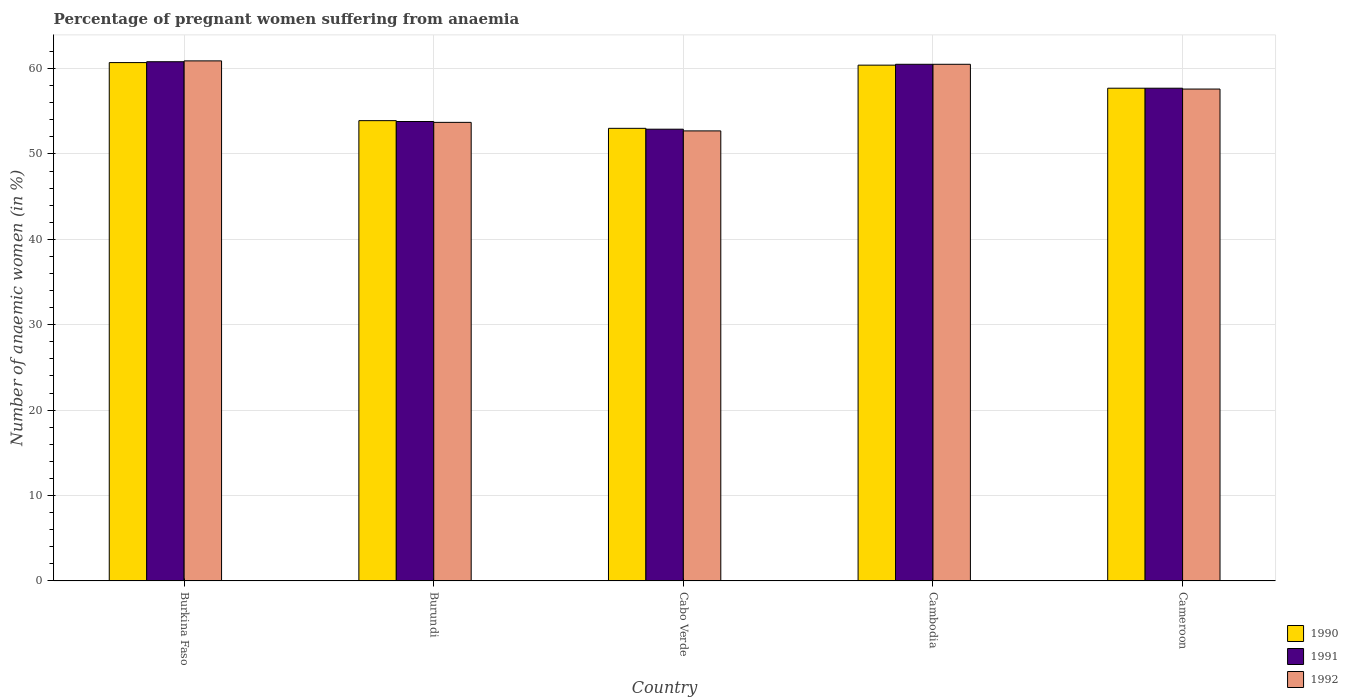How many different coloured bars are there?
Provide a succinct answer. 3. How many groups of bars are there?
Keep it short and to the point. 5. Are the number of bars on each tick of the X-axis equal?
Make the answer very short. Yes. How many bars are there on the 1st tick from the right?
Offer a very short reply. 3. What is the label of the 5th group of bars from the left?
Provide a succinct answer. Cameroon. What is the number of anaemic women in 1991 in Burundi?
Ensure brevity in your answer.  53.8. Across all countries, what is the maximum number of anaemic women in 1992?
Your answer should be very brief. 60.9. Across all countries, what is the minimum number of anaemic women in 1991?
Keep it short and to the point. 52.9. In which country was the number of anaemic women in 1991 maximum?
Ensure brevity in your answer.  Burkina Faso. In which country was the number of anaemic women in 1991 minimum?
Give a very brief answer. Cabo Verde. What is the total number of anaemic women in 1990 in the graph?
Give a very brief answer. 285.7. What is the difference between the number of anaemic women in 1992 in Burundi and that in Cambodia?
Offer a terse response. -6.8. What is the difference between the number of anaemic women in 1990 in Cabo Verde and the number of anaemic women in 1991 in Burkina Faso?
Make the answer very short. -7.8. What is the average number of anaemic women in 1992 per country?
Make the answer very short. 57.08. What is the difference between the number of anaemic women of/in 1990 and number of anaemic women of/in 1992 in Cabo Verde?
Make the answer very short. 0.3. In how many countries, is the number of anaemic women in 1991 greater than 26 %?
Your response must be concise. 5. What is the ratio of the number of anaemic women in 1990 in Burundi to that in Cambodia?
Your answer should be very brief. 0.89. What is the difference between the highest and the lowest number of anaemic women in 1990?
Ensure brevity in your answer.  7.7. In how many countries, is the number of anaemic women in 1990 greater than the average number of anaemic women in 1990 taken over all countries?
Your response must be concise. 3. How many countries are there in the graph?
Your answer should be very brief. 5. Are the values on the major ticks of Y-axis written in scientific E-notation?
Your answer should be compact. No. Does the graph contain grids?
Give a very brief answer. Yes. Where does the legend appear in the graph?
Offer a very short reply. Bottom right. How many legend labels are there?
Your response must be concise. 3. What is the title of the graph?
Provide a short and direct response. Percentage of pregnant women suffering from anaemia. Does "2001" appear as one of the legend labels in the graph?
Ensure brevity in your answer.  No. What is the label or title of the Y-axis?
Offer a terse response. Number of anaemic women (in %). What is the Number of anaemic women (in %) of 1990 in Burkina Faso?
Ensure brevity in your answer.  60.7. What is the Number of anaemic women (in %) in 1991 in Burkina Faso?
Provide a succinct answer. 60.8. What is the Number of anaemic women (in %) in 1992 in Burkina Faso?
Keep it short and to the point. 60.9. What is the Number of anaemic women (in %) in 1990 in Burundi?
Keep it short and to the point. 53.9. What is the Number of anaemic women (in %) of 1991 in Burundi?
Offer a very short reply. 53.8. What is the Number of anaemic women (in %) in 1992 in Burundi?
Provide a succinct answer. 53.7. What is the Number of anaemic women (in %) of 1990 in Cabo Verde?
Offer a very short reply. 53. What is the Number of anaemic women (in %) in 1991 in Cabo Verde?
Your answer should be very brief. 52.9. What is the Number of anaemic women (in %) in 1992 in Cabo Verde?
Provide a succinct answer. 52.7. What is the Number of anaemic women (in %) of 1990 in Cambodia?
Give a very brief answer. 60.4. What is the Number of anaemic women (in %) in 1991 in Cambodia?
Provide a short and direct response. 60.5. What is the Number of anaemic women (in %) of 1992 in Cambodia?
Keep it short and to the point. 60.5. What is the Number of anaemic women (in %) of 1990 in Cameroon?
Make the answer very short. 57.7. What is the Number of anaemic women (in %) of 1991 in Cameroon?
Provide a short and direct response. 57.7. What is the Number of anaemic women (in %) in 1992 in Cameroon?
Make the answer very short. 57.6. Across all countries, what is the maximum Number of anaemic women (in %) of 1990?
Give a very brief answer. 60.7. Across all countries, what is the maximum Number of anaemic women (in %) in 1991?
Make the answer very short. 60.8. Across all countries, what is the maximum Number of anaemic women (in %) of 1992?
Offer a very short reply. 60.9. Across all countries, what is the minimum Number of anaemic women (in %) in 1990?
Give a very brief answer. 53. Across all countries, what is the minimum Number of anaemic women (in %) of 1991?
Provide a succinct answer. 52.9. Across all countries, what is the minimum Number of anaemic women (in %) in 1992?
Keep it short and to the point. 52.7. What is the total Number of anaemic women (in %) of 1990 in the graph?
Offer a terse response. 285.7. What is the total Number of anaemic women (in %) of 1991 in the graph?
Your answer should be compact. 285.7. What is the total Number of anaemic women (in %) in 1992 in the graph?
Give a very brief answer. 285.4. What is the difference between the Number of anaemic women (in %) in 1990 in Burkina Faso and that in Burundi?
Keep it short and to the point. 6.8. What is the difference between the Number of anaemic women (in %) in 1990 in Burkina Faso and that in Cabo Verde?
Give a very brief answer. 7.7. What is the difference between the Number of anaemic women (in %) of 1991 in Burkina Faso and that in Cabo Verde?
Provide a short and direct response. 7.9. What is the difference between the Number of anaemic women (in %) of 1990 in Burkina Faso and that in Cameroon?
Offer a terse response. 3. What is the difference between the Number of anaemic women (in %) of 1991 in Burkina Faso and that in Cameroon?
Give a very brief answer. 3.1. What is the difference between the Number of anaemic women (in %) of 1990 in Burundi and that in Cabo Verde?
Provide a short and direct response. 0.9. What is the difference between the Number of anaemic women (in %) of 1992 in Burundi and that in Cabo Verde?
Offer a very short reply. 1. What is the difference between the Number of anaemic women (in %) in 1990 in Burundi and that in Cambodia?
Keep it short and to the point. -6.5. What is the difference between the Number of anaemic women (in %) in 1992 in Burundi and that in Cameroon?
Provide a succinct answer. -3.9. What is the difference between the Number of anaemic women (in %) of 1990 in Cabo Verde and that in Cambodia?
Your response must be concise. -7.4. What is the difference between the Number of anaemic women (in %) in 1991 in Cabo Verde and that in Cambodia?
Keep it short and to the point. -7.6. What is the difference between the Number of anaemic women (in %) in 1990 in Cabo Verde and that in Cameroon?
Offer a very short reply. -4.7. What is the difference between the Number of anaemic women (in %) in 1991 in Cabo Verde and that in Cameroon?
Offer a terse response. -4.8. What is the difference between the Number of anaemic women (in %) in 1990 in Cambodia and that in Cameroon?
Provide a short and direct response. 2.7. What is the difference between the Number of anaemic women (in %) of 1991 in Cambodia and that in Cameroon?
Make the answer very short. 2.8. What is the difference between the Number of anaemic women (in %) of 1990 in Burkina Faso and the Number of anaemic women (in %) of 1991 in Burundi?
Your answer should be compact. 6.9. What is the difference between the Number of anaemic women (in %) of 1990 in Burkina Faso and the Number of anaemic women (in %) of 1992 in Burundi?
Your response must be concise. 7. What is the difference between the Number of anaemic women (in %) of 1990 in Burkina Faso and the Number of anaemic women (in %) of 1992 in Cabo Verde?
Your answer should be compact. 8. What is the difference between the Number of anaemic women (in %) in 1990 in Burkina Faso and the Number of anaemic women (in %) in 1992 in Cambodia?
Your answer should be very brief. 0.2. What is the difference between the Number of anaemic women (in %) in 1991 in Burkina Faso and the Number of anaemic women (in %) in 1992 in Cambodia?
Ensure brevity in your answer.  0.3. What is the difference between the Number of anaemic women (in %) of 1990 in Burkina Faso and the Number of anaemic women (in %) of 1992 in Cameroon?
Provide a succinct answer. 3.1. What is the difference between the Number of anaemic women (in %) in 1990 in Burundi and the Number of anaemic women (in %) in 1992 in Cabo Verde?
Offer a terse response. 1.2. What is the difference between the Number of anaemic women (in %) in 1991 in Burundi and the Number of anaemic women (in %) in 1992 in Cabo Verde?
Ensure brevity in your answer.  1.1. What is the difference between the Number of anaemic women (in %) in 1990 in Burundi and the Number of anaemic women (in %) in 1991 in Cambodia?
Make the answer very short. -6.6. What is the difference between the Number of anaemic women (in %) of 1990 in Burundi and the Number of anaemic women (in %) of 1992 in Cambodia?
Keep it short and to the point. -6.6. What is the difference between the Number of anaemic women (in %) of 1990 in Burundi and the Number of anaemic women (in %) of 1992 in Cameroon?
Provide a succinct answer. -3.7. What is the difference between the Number of anaemic women (in %) of 1990 in Cabo Verde and the Number of anaemic women (in %) of 1991 in Cambodia?
Offer a terse response. -7.5. What is the difference between the Number of anaemic women (in %) of 1991 in Cabo Verde and the Number of anaemic women (in %) of 1992 in Cambodia?
Provide a succinct answer. -7.6. What is the difference between the Number of anaemic women (in %) of 1990 in Cabo Verde and the Number of anaemic women (in %) of 1992 in Cameroon?
Offer a terse response. -4.6. What is the difference between the Number of anaemic women (in %) in 1991 in Cabo Verde and the Number of anaemic women (in %) in 1992 in Cameroon?
Give a very brief answer. -4.7. What is the average Number of anaemic women (in %) in 1990 per country?
Ensure brevity in your answer.  57.14. What is the average Number of anaemic women (in %) in 1991 per country?
Keep it short and to the point. 57.14. What is the average Number of anaemic women (in %) in 1992 per country?
Offer a terse response. 57.08. What is the difference between the Number of anaemic women (in %) of 1990 and Number of anaemic women (in %) of 1991 in Burkina Faso?
Provide a short and direct response. -0.1. What is the difference between the Number of anaemic women (in %) of 1991 and Number of anaemic women (in %) of 1992 in Burkina Faso?
Make the answer very short. -0.1. What is the difference between the Number of anaemic women (in %) in 1990 and Number of anaemic women (in %) in 1991 in Burundi?
Provide a succinct answer. 0.1. What is the difference between the Number of anaemic women (in %) in 1990 and Number of anaemic women (in %) in 1992 in Burundi?
Provide a short and direct response. 0.2. What is the difference between the Number of anaemic women (in %) in 1990 and Number of anaemic women (in %) in 1992 in Cabo Verde?
Make the answer very short. 0.3. What is the difference between the Number of anaemic women (in %) in 1990 and Number of anaemic women (in %) in 1992 in Cambodia?
Keep it short and to the point. -0.1. What is the ratio of the Number of anaemic women (in %) in 1990 in Burkina Faso to that in Burundi?
Give a very brief answer. 1.13. What is the ratio of the Number of anaemic women (in %) of 1991 in Burkina Faso to that in Burundi?
Your response must be concise. 1.13. What is the ratio of the Number of anaemic women (in %) of 1992 in Burkina Faso to that in Burundi?
Keep it short and to the point. 1.13. What is the ratio of the Number of anaemic women (in %) of 1990 in Burkina Faso to that in Cabo Verde?
Provide a short and direct response. 1.15. What is the ratio of the Number of anaemic women (in %) of 1991 in Burkina Faso to that in Cabo Verde?
Your answer should be very brief. 1.15. What is the ratio of the Number of anaemic women (in %) of 1992 in Burkina Faso to that in Cabo Verde?
Ensure brevity in your answer.  1.16. What is the ratio of the Number of anaemic women (in %) of 1991 in Burkina Faso to that in Cambodia?
Your answer should be compact. 1. What is the ratio of the Number of anaemic women (in %) in 1992 in Burkina Faso to that in Cambodia?
Provide a short and direct response. 1.01. What is the ratio of the Number of anaemic women (in %) of 1990 in Burkina Faso to that in Cameroon?
Your response must be concise. 1.05. What is the ratio of the Number of anaemic women (in %) of 1991 in Burkina Faso to that in Cameroon?
Provide a succinct answer. 1.05. What is the ratio of the Number of anaemic women (in %) of 1992 in Burkina Faso to that in Cameroon?
Provide a short and direct response. 1.06. What is the ratio of the Number of anaemic women (in %) in 1990 in Burundi to that in Cabo Verde?
Give a very brief answer. 1.02. What is the ratio of the Number of anaemic women (in %) of 1992 in Burundi to that in Cabo Verde?
Your response must be concise. 1.02. What is the ratio of the Number of anaemic women (in %) of 1990 in Burundi to that in Cambodia?
Give a very brief answer. 0.89. What is the ratio of the Number of anaemic women (in %) of 1991 in Burundi to that in Cambodia?
Ensure brevity in your answer.  0.89. What is the ratio of the Number of anaemic women (in %) of 1992 in Burundi to that in Cambodia?
Offer a terse response. 0.89. What is the ratio of the Number of anaemic women (in %) of 1990 in Burundi to that in Cameroon?
Provide a short and direct response. 0.93. What is the ratio of the Number of anaemic women (in %) of 1991 in Burundi to that in Cameroon?
Your answer should be compact. 0.93. What is the ratio of the Number of anaemic women (in %) in 1992 in Burundi to that in Cameroon?
Provide a succinct answer. 0.93. What is the ratio of the Number of anaemic women (in %) of 1990 in Cabo Verde to that in Cambodia?
Provide a succinct answer. 0.88. What is the ratio of the Number of anaemic women (in %) of 1991 in Cabo Verde to that in Cambodia?
Your answer should be very brief. 0.87. What is the ratio of the Number of anaemic women (in %) in 1992 in Cabo Verde to that in Cambodia?
Provide a succinct answer. 0.87. What is the ratio of the Number of anaemic women (in %) of 1990 in Cabo Verde to that in Cameroon?
Your answer should be compact. 0.92. What is the ratio of the Number of anaemic women (in %) in 1991 in Cabo Verde to that in Cameroon?
Your answer should be very brief. 0.92. What is the ratio of the Number of anaemic women (in %) of 1992 in Cabo Verde to that in Cameroon?
Ensure brevity in your answer.  0.91. What is the ratio of the Number of anaemic women (in %) of 1990 in Cambodia to that in Cameroon?
Offer a terse response. 1.05. What is the ratio of the Number of anaemic women (in %) of 1991 in Cambodia to that in Cameroon?
Offer a terse response. 1.05. What is the ratio of the Number of anaemic women (in %) of 1992 in Cambodia to that in Cameroon?
Offer a terse response. 1.05. What is the difference between the highest and the second highest Number of anaemic women (in %) of 1990?
Make the answer very short. 0.3. What is the difference between the highest and the second highest Number of anaemic women (in %) of 1991?
Make the answer very short. 0.3. What is the difference between the highest and the lowest Number of anaemic women (in %) in 1991?
Your answer should be very brief. 7.9. 